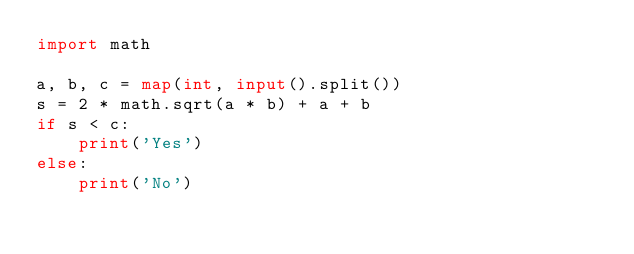Convert code to text. <code><loc_0><loc_0><loc_500><loc_500><_Python_>import math

a, b, c = map(int, input().split())
s = 2 * math.sqrt(a * b) + a + b
if s < c:
    print('Yes')
else:
    print('No')
</code> 